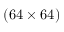Convert formula to latex. <formula><loc_0><loc_0><loc_500><loc_500>( 6 4 \times 6 4 )</formula> 